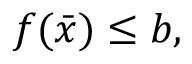Convert formula to latex. <formula><loc_0><loc_0><loc_500><loc_500>f ( { \bar { x } } ) \leq b ,</formula> 